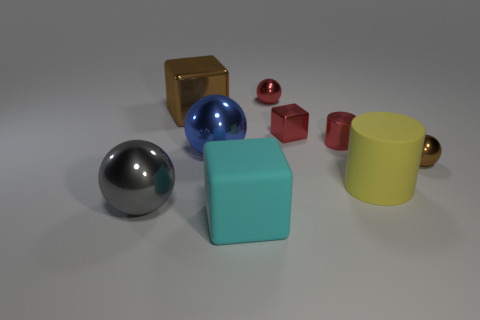There is a big block that is in front of the large metal thing in front of the yellow matte cylinder; is there a shiny cylinder that is on the left side of it? no 